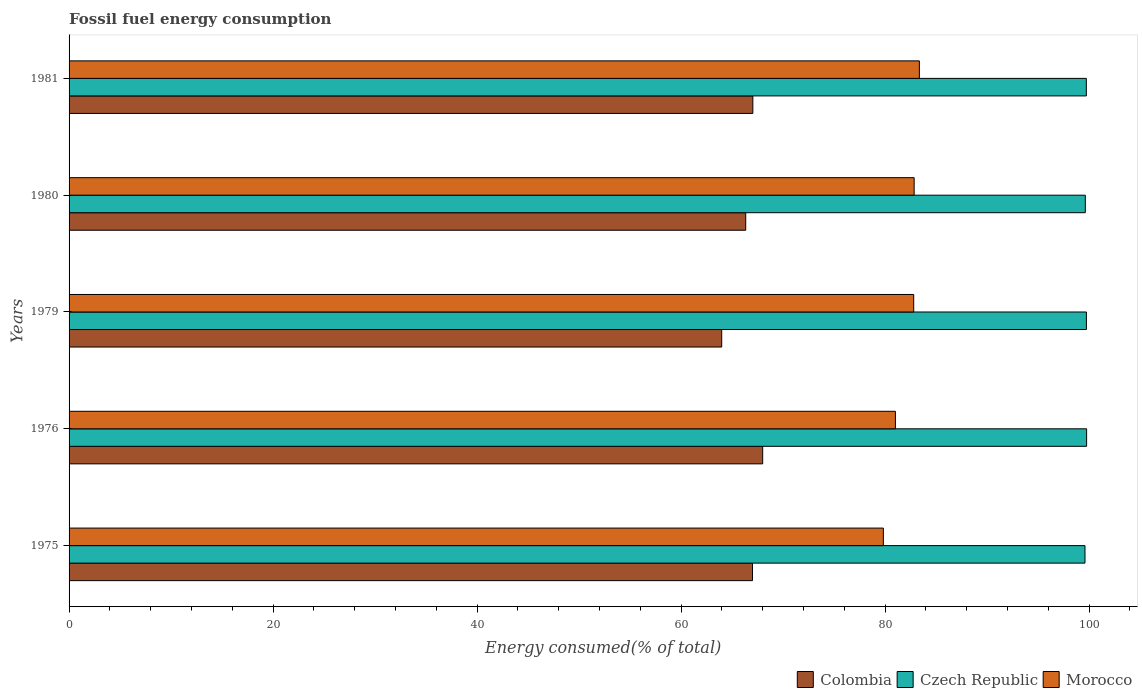Are the number of bars per tick equal to the number of legend labels?
Ensure brevity in your answer.  Yes. How many bars are there on the 3rd tick from the top?
Keep it short and to the point. 3. How many bars are there on the 1st tick from the bottom?
Keep it short and to the point. 3. What is the label of the 4th group of bars from the top?
Give a very brief answer. 1976. In how many cases, is the number of bars for a given year not equal to the number of legend labels?
Your answer should be compact. 0. What is the percentage of energy consumed in Morocco in 1981?
Offer a terse response. 83.36. Across all years, what is the maximum percentage of energy consumed in Colombia?
Provide a succinct answer. 68. Across all years, what is the minimum percentage of energy consumed in Colombia?
Give a very brief answer. 63.98. In which year was the percentage of energy consumed in Czech Republic maximum?
Keep it short and to the point. 1976. In which year was the percentage of energy consumed in Morocco minimum?
Your answer should be compact. 1975. What is the total percentage of energy consumed in Morocco in the graph?
Your answer should be very brief. 409.84. What is the difference between the percentage of energy consumed in Morocco in 1975 and that in 1976?
Your answer should be very brief. -1.18. What is the difference between the percentage of energy consumed in Czech Republic in 1980 and the percentage of energy consumed in Morocco in 1976?
Provide a short and direct response. 18.62. What is the average percentage of energy consumed in Morocco per year?
Make the answer very short. 81.97. In the year 1975, what is the difference between the percentage of energy consumed in Czech Republic and percentage of energy consumed in Morocco?
Keep it short and to the point. 19.77. What is the ratio of the percentage of energy consumed in Czech Republic in 1975 to that in 1981?
Provide a short and direct response. 1. Is the percentage of energy consumed in Czech Republic in 1976 less than that in 1980?
Provide a succinct answer. No. Is the difference between the percentage of energy consumed in Czech Republic in 1980 and 1981 greater than the difference between the percentage of energy consumed in Morocco in 1980 and 1981?
Your response must be concise. Yes. What is the difference between the highest and the second highest percentage of energy consumed in Morocco?
Offer a terse response. 0.51. What is the difference between the highest and the lowest percentage of energy consumed in Czech Republic?
Offer a terse response. 0.16. In how many years, is the percentage of energy consumed in Colombia greater than the average percentage of energy consumed in Colombia taken over all years?
Your answer should be very brief. 3. Is the sum of the percentage of energy consumed in Colombia in 1976 and 1980 greater than the maximum percentage of energy consumed in Morocco across all years?
Provide a succinct answer. Yes. What does the 2nd bar from the bottom in 1976 represents?
Keep it short and to the point. Czech Republic. How many years are there in the graph?
Provide a succinct answer. 5. Are the values on the major ticks of X-axis written in scientific E-notation?
Offer a terse response. No. Does the graph contain any zero values?
Your response must be concise. No. Does the graph contain grids?
Your answer should be very brief. No. Where does the legend appear in the graph?
Offer a very short reply. Bottom right. How many legend labels are there?
Offer a very short reply. 3. What is the title of the graph?
Ensure brevity in your answer.  Fossil fuel energy consumption. Does "Iceland" appear as one of the legend labels in the graph?
Offer a very short reply. No. What is the label or title of the X-axis?
Provide a short and direct response. Energy consumed(% of total). What is the label or title of the Y-axis?
Provide a succinct answer. Years. What is the Energy consumed(% of total) in Colombia in 1975?
Ensure brevity in your answer.  67. What is the Energy consumed(% of total) of Czech Republic in 1975?
Give a very brief answer. 99.59. What is the Energy consumed(% of total) of Morocco in 1975?
Your answer should be very brief. 79.83. What is the Energy consumed(% of total) of Colombia in 1976?
Your answer should be compact. 68. What is the Energy consumed(% of total) in Czech Republic in 1976?
Your answer should be very brief. 99.75. What is the Energy consumed(% of total) of Morocco in 1976?
Your response must be concise. 81.01. What is the Energy consumed(% of total) of Colombia in 1979?
Ensure brevity in your answer.  63.98. What is the Energy consumed(% of total) in Czech Republic in 1979?
Keep it short and to the point. 99.73. What is the Energy consumed(% of total) in Morocco in 1979?
Keep it short and to the point. 82.8. What is the Energy consumed(% of total) of Colombia in 1980?
Your answer should be very brief. 66.33. What is the Energy consumed(% of total) in Czech Republic in 1980?
Your answer should be compact. 99.62. What is the Energy consumed(% of total) of Morocco in 1980?
Keep it short and to the point. 82.85. What is the Energy consumed(% of total) in Colombia in 1981?
Your answer should be very brief. 67.03. What is the Energy consumed(% of total) in Czech Republic in 1981?
Give a very brief answer. 99.72. What is the Energy consumed(% of total) of Morocco in 1981?
Your response must be concise. 83.36. Across all years, what is the maximum Energy consumed(% of total) in Colombia?
Provide a succinct answer. 68. Across all years, what is the maximum Energy consumed(% of total) of Czech Republic?
Make the answer very short. 99.75. Across all years, what is the maximum Energy consumed(% of total) in Morocco?
Keep it short and to the point. 83.36. Across all years, what is the minimum Energy consumed(% of total) of Colombia?
Provide a succinct answer. 63.98. Across all years, what is the minimum Energy consumed(% of total) of Czech Republic?
Ensure brevity in your answer.  99.59. Across all years, what is the minimum Energy consumed(% of total) of Morocco?
Keep it short and to the point. 79.83. What is the total Energy consumed(% of total) in Colombia in the graph?
Your answer should be compact. 332.34. What is the total Energy consumed(% of total) of Czech Republic in the graph?
Keep it short and to the point. 498.42. What is the total Energy consumed(% of total) of Morocco in the graph?
Your response must be concise. 409.84. What is the difference between the Energy consumed(% of total) of Colombia in 1975 and that in 1976?
Your response must be concise. -1. What is the difference between the Energy consumed(% of total) in Czech Republic in 1975 and that in 1976?
Make the answer very short. -0.16. What is the difference between the Energy consumed(% of total) in Morocco in 1975 and that in 1976?
Provide a short and direct response. -1.18. What is the difference between the Energy consumed(% of total) in Colombia in 1975 and that in 1979?
Offer a terse response. 3.02. What is the difference between the Energy consumed(% of total) of Czech Republic in 1975 and that in 1979?
Your answer should be compact. -0.14. What is the difference between the Energy consumed(% of total) in Morocco in 1975 and that in 1979?
Ensure brevity in your answer.  -2.97. What is the difference between the Energy consumed(% of total) of Colombia in 1975 and that in 1980?
Offer a very short reply. 0.66. What is the difference between the Energy consumed(% of total) in Czech Republic in 1975 and that in 1980?
Provide a succinct answer. -0.03. What is the difference between the Energy consumed(% of total) of Morocco in 1975 and that in 1980?
Your answer should be compact. -3.02. What is the difference between the Energy consumed(% of total) in Colombia in 1975 and that in 1981?
Ensure brevity in your answer.  -0.03. What is the difference between the Energy consumed(% of total) in Czech Republic in 1975 and that in 1981?
Provide a succinct answer. -0.13. What is the difference between the Energy consumed(% of total) of Morocco in 1975 and that in 1981?
Offer a terse response. -3.53. What is the difference between the Energy consumed(% of total) of Colombia in 1976 and that in 1979?
Offer a very short reply. 4.02. What is the difference between the Energy consumed(% of total) of Czech Republic in 1976 and that in 1979?
Ensure brevity in your answer.  0.02. What is the difference between the Energy consumed(% of total) of Morocco in 1976 and that in 1979?
Offer a terse response. -1.79. What is the difference between the Energy consumed(% of total) of Colombia in 1976 and that in 1980?
Your answer should be compact. 1.66. What is the difference between the Energy consumed(% of total) of Czech Republic in 1976 and that in 1980?
Give a very brief answer. 0.13. What is the difference between the Energy consumed(% of total) of Morocco in 1976 and that in 1980?
Offer a terse response. -1.84. What is the difference between the Energy consumed(% of total) in Colombia in 1976 and that in 1981?
Provide a succinct answer. 0.96. What is the difference between the Energy consumed(% of total) in Czech Republic in 1976 and that in 1981?
Offer a very short reply. 0.03. What is the difference between the Energy consumed(% of total) in Morocco in 1976 and that in 1981?
Your answer should be very brief. -2.35. What is the difference between the Energy consumed(% of total) in Colombia in 1979 and that in 1980?
Give a very brief answer. -2.35. What is the difference between the Energy consumed(% of total) of Czech Republic in 1979 and that in 1980?
Offer a terse response. 0.11. What is the difference between the Energy consumed(% of total) in Morocco in 1979 and that in 1980?
Make the answer very short. -0.05. What is the difference between the Energy consumed(% of total) in Colombia in 1979 and that in 1981?
Your response must be concise. -3.05. What is the difference between the Energy consumed(% of total) in Czech Republic in 1979 and that in 1981?
Your answer should be very brief. 0.01. What is the difference between the Energy consumed(% of total) in Morocco in 1979 and that in 1981?
Your response must be concise. -0.56. What is the difference between the Energy consumed(% of total) of Colombia in 1980 and that in 1981?
Make the answer very short. -0.7. What is the difference between the Energy consumed(% of total) in Czech Republic in 1980 and that in 1981?
Your response must be concise. -0.1. What is the difference between the Energy consumed(% of total) of Morocco in 1980 and that in 1981?
Give a very brief answer. -0.51. What is the difference between the Energy consumed(% of total) in Colombia in 1975 and the Energy consumed(% of total) in Czech Republic in 1976?
Give a very brief answer. -32.75. What is the difference between the Energy consumed(% of total) in Colombia in 1975 and the Energy consumed(% of total) in Morocco in 1976?
Your response must be concise. -14.01. What is the difference between the Energy consumed(% of total) in Czech Republic in 1975 and the Energy consumed(% of total) in Morocco in 1976?
Offer a very short reply. 18.58. What is the difference between the Energy consumed(% of total) of Colombia in 1975 and the Energy consumed(% of total) of Czech Republic in 1979?
Ensure brevity in your answer.  -32.73. What is the difference between the Energy consumed(% of total) of Colombia in 1975 and the Energy consumed(% of total) of Morocco in 1979?
Provide a succinct answer. -15.8. What is the difference between the Energy consumed(% of total) in Czech Republic in 1975 and the Energy consumed(% of total) in Morocco in 1979?
Offer a terse response. 16.79. What is the difference between the Energy consumed(% of total) of Colombia in 1975 and the Energy consumed(% of total) of Czech Republic in 1980?
Offer a very short reply. -32.63. What is the difference between the Energy consumed(% of total) of Colombia in 1975 and the Energy consumed(% of total) of Morocco in 1980?
Give a very brief answer. -15.85. What is the difference between the Energy consumed(% of total) of Czech Republic in 1975 and the Energy consumed(% of total) of Morocco in 1980?
Offer a very short reply. 16.75. What is the difference between the Energy consumed(% of total) in Colombia in 1975 and the Energy consumed(% of total) in Czech Republic in 1981?
Your answer should be compact. -32.73. What is the difference between the Energy consumed(% of total) in Colombia in 1975 and the Energy consumed(% of total) in Morocco in 1981?
Make the answer very short. -16.36. What is the difference between the Energy consumed(% of total) of Czech Republic in 1975 and the Energy consumed(% of total) of Morocco in 1981?
Keep it short and to the point. 16.24. What is the difference between the Energy consumed(% of total) in Colombia in 1976 and the Energy consumed(% of total) in Czech Republic in 1979?
Ensure brevity in your answer.  -31.74. What is the difference between the Energy consumed(% of total) of Colombia in 1976 and the Energy consumed(% of total) of Morocco in 1979?
Provide a succinct answer. -14.8. What is the difference between the Energy consumed(% of total) in Czech Republic in 1976 and the Energy consumed(% of total) in Morocco in 1979?
Provide a short and direct response. 16.95. What is the difference between the Energy consumed(% of total) of Colombia in 1976 and the Energy consumed(% of total) of Czech Republic in 1980?
Your response must be concise. -31.63. What is the difference between the Energy consumed(% of total) of Colombia in 1976 and the Energy consumed(% of total) of Morocco in 1980?
Your answer should be compact. -14.85. What is the difference between the Energy consumed(% of total) of Czech Republic in 1976 and the Energy consumed(% of total) of Morocco in 1980?
Your response must be concise. 16.91. What is the difference between the Energy consumed(% of total) in Colombia in 1976 and the Energy consumed(% of total) in Czech Republic in 1981?
Keep it short and to the point. -31.73. What is the difference between the Energy consumed(% of total) of Colombia in 1976 and the Energy consumed(% of total) of Morocco in 1981?
Your answer should be compact. -15.36. What is the difference between the Energy consumed(% of total) in Czech Republic in 1976 and the Energy consumed(% of total) in Morocco in 1981?
Offer a terse response. 16.4. What is the difference between the Energy consumed(% of total) in Colombia in 1979 and the Energy consumed(% of total) in Czech Republic in 1980?
Provide a succinct answer. -35.65. What is the difference between the Energy consumed(% of total) of Colombia in 1979 and the Energy consumed(% of total) of Morocco in 1980?
Your answer should be very brief. -18.87. What is the difference between the Energy consumed(% of total) of Czech Republic in 1979 and the Energy consumed(% of total) of Morocco in 1980?
Ensure brevity in your answer.  16.89. What is the difference between the Energy consumed(% of total) in Colombia in 1979 and the Energy consumed(% of total) in Czech Republic in 1981?
Your answer should be very brief. -35.75. What is the difference between the Energy consumed(% of total) in Colombia in 1979 and the Energy consumed(% of total) in Morocco in 1981?
Your answer should be compact. -19.38. What is the difference between the Energy consumed(% of total) of Czech Republic in 1979 and the Energy consumed(% of total) of Morocco in 1981?
Your answer should be very brief. 16.38. What is the difference between the Energy consumed(% of total) in Colombia in 1980 and the Energy consumed(% of total) in Czech Republic in 1981?
Provide a succinct answer. -33.39. What is the difference between the Energy consumed(% of total) in Colombia in 1980 and the Energy consumed(% of total) in Morocco in 1981?
Offer a very short reply. -17.02. What is the difference between the Energy consumed(% of total) in Czech Republic in 1980 and the Energy consumed(% of total) in Morocco in 1981?
Keep it short and to the point. 16.27. What is the average Energy consumed(% of total) in Colombia per year?
Make the answer very short. 66.47. What is the average Energy consumed(% of total) of Czech Republic per year?
Give a very brief answer. 99.68. What is the average Energy consumed(% of total) in Morocco per year?
Your answer should be very brief. 81.97. In the year 1975, what is the difference between the Energy consumed(% of total) of Colombia and Energy consumed(% of total) of Czech Republic?
Give a very brief answer. -32.59. In the year 1975, what is the difference between the Energy consumed(% of total) in Colombia and Energy consumed(% of total) in Morocco?
Provide a short and direct response. -12.83. In the year 1975, what is the difference between the Energy consumed(% of total) in Czech Republic and Energy consumed(% of total) in Morocco?
Provide a short and direct response. 19.77. In the year 1976, what is the difference between the Energy consumed(% of total) in Colombia and Energy consumed(% of total) in Czech Republic?
Offer a very short reply. -31.76. In the year 1976, what is the difference between the Energy consumed(% of total) of Colombia and Energy consumed(% of total) of Morocco?
Make the answer very short. -13.01. In the year 1976, what is the difference between the Energy consumed(% of total) of Czech Republic and Energy consumed(% of total) of Morocco?
Your answer should be very brief. 18.74. In the year 1979, what is the difference between the Energy consumed(% of total) of Colombia and Energy consumed(% of total) of Czech Republic?
Make the answer very short. -35.75. In the year 1979, what is the difference between the Energy consumed(% of total) of Colombia and Energy consumed(% of total) of Morocco?
Your answer should be compact. -18.82. In the year 1979, what is the difference between the Energy consumed(% of total) in Czech Republic and Energy consumed(% of total) in Morocco?
Provide a succinct answer. 16.93. In the year 1980, what is the difference between the Energy consumed(% of total) of Colombia and Energy consumed(% of total) of Czech Republic?
Provide a short and direct response. -33.29. In the year 1980, what is the difference between the Energy consumed(% of total) in Colombia and Energy consumed(% of total) in Morocco?
Give a very brief answer. -16.51. In the year 1980, what is the difference between the Energy consumed(% of total) in Czech Republic and Energy consumed(% of total) in Morocco?
Your answer should be very brief. 16.78. In the year 1981, what is the difference between the Energy consumed(% of total) in Colombia and Energy consumed(% of total) in Czech Republic?
Provide a short and direct response. -32.69. In the year 1981, what is the difference between the Energy consumed(% of total) in Colombia and Energy consumed(% of total) in Morocco?
Offer a very short reply. -16.32. In the year 1981, what is the difference between the Energy consumed(% of total) in Czech Republic and Energy consumed(% of total) in Morocco?
Provide a short and direct response. 16.37. What is the ratio of the Energy consumed(% of total) of Morocco in 1975 to that in 1976?
Make the answer very short. 0.99. What is the ratio of the Energy consumed(% of total) of Colombia in 1975 to that in 1979?
Give a very brief answer. 1.05. What is the ratio of the Energy consumed(% of total) in Morocco in 1975 to that in 1979?
Ensure brevity in your answer.  0.96. What is the ratio of the Energy consumed(% of total) in Colombia in 1975 to that in 1980?
Offer a very short reply. 1.01. What is the ratio of the Energy consumed(% of total) of Czech Republic in 1975 to that in 1980?
Your answer should be very brief. 1. What is the ratio of the Energy consumed(% of total) of Morocco in 1975 to that in 1980?
Offer a terse response. 0.96. What is the ratio of the Energy consumed(% of total) of Colombia in 1975 to that in 1981?
Offer a very short reply. 1. What is the ratio of the Energy consumed(% of total) in Morocco in 1975 to that in 1981?
Your answer should be compact. 0.96. What is the ratio of the Energy consumed(% of total) in Colombia in 1976 to that in 1979?
Offer a very short reply. 1.06. What is the ratio of the Energy consumed(% of total) in Czech Republic in 1976 to that in 1979?
Make the answer very short. 1. What is the ratio of the Energy consumed(% of total) in Morocco in 1976 to that in 1979?
Your answer should be compact. 0.98. What is the ratio of the Energy consumed(% of total) in Colombia in 1976 to that in 1980?
Your answer should be compact. 1.03. What is the ratio of the Energy consumed(% of total) in Czech Republic in 1976 to that in 1980?
Ensure brevity in your answer.  1. What is the ratio of the Energy consumed(% of total) in Morocco in 1976 to that in 1980?
Ensure brevity in your answer.  0.98. What is the ratio of the Energy consumed(% of total) of Colombia in 1976 to that in 1981?
Give a very brief answer. 1.01. What is the ratio of the Energy consumed(% of total) of Czech Republic in 1976 to that in 1981?
Keep it short and to the point. 1. What is the ratio of the Energy consumed(% of total) in Morocco in 1976 to that in 1981?
Your answer should be very brief. 0.97. What is the ratio of the Energy consumed(% of total) in Colombia in 1979 to that in 1980?
Your answer should be very brief. 0.96. What is the ratio of the Energy consumed(% of total) in Morocco in 1979 to that in 1980?
Offer a very short reply. 1. What is the ratio of the Energy consumed(% of total) in Colombia in 1979 to that in 1981?
Your response must be concise. 0.95. What is the ratio of the Energy consumed(% of total) in Morocco in 1979 to that in 1981?
Keep it short and to the point. 0.99. What is the ratio of the Energy consumed(% of total) of Morocco in 1980 to that in 1981?
Make the answer very short. 0.99. What is the difference between the highest and the second highest Energy consumed(% of total) in Colombia?
Offer a very short reply. 0.96. What is the difference between the highest and the second highest Energy consumed(% of total) of Czech Republic?
Provide a short and direct response. 0.02. What is the difference between the highest and the second highest Energy consumed(% of total) in Morocco?
Keep it short and to the point. 0.51. What is the difference between the highest and the lowest Energy consumed(% of total) of Colombia?
Offer a terse response. 4.02. What is the difference between the highest and the lowest Energy consumed(% of total) in Czech Republic?
Your answer should be very brief. 0.16. What is the difference between the highest and the lowest Energy consumed(% of total) of Morocco?
Make the answer very short. 3.53. 